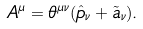Convert formula to latex. <formula><loc_0><loc_0><loc_500><loc_500>A ^ { \mu } = \theta ^ { \mu \nu } ( \hat { p } _ { \nu } + \tilde { a } _ { \nu } ) .</formula> 